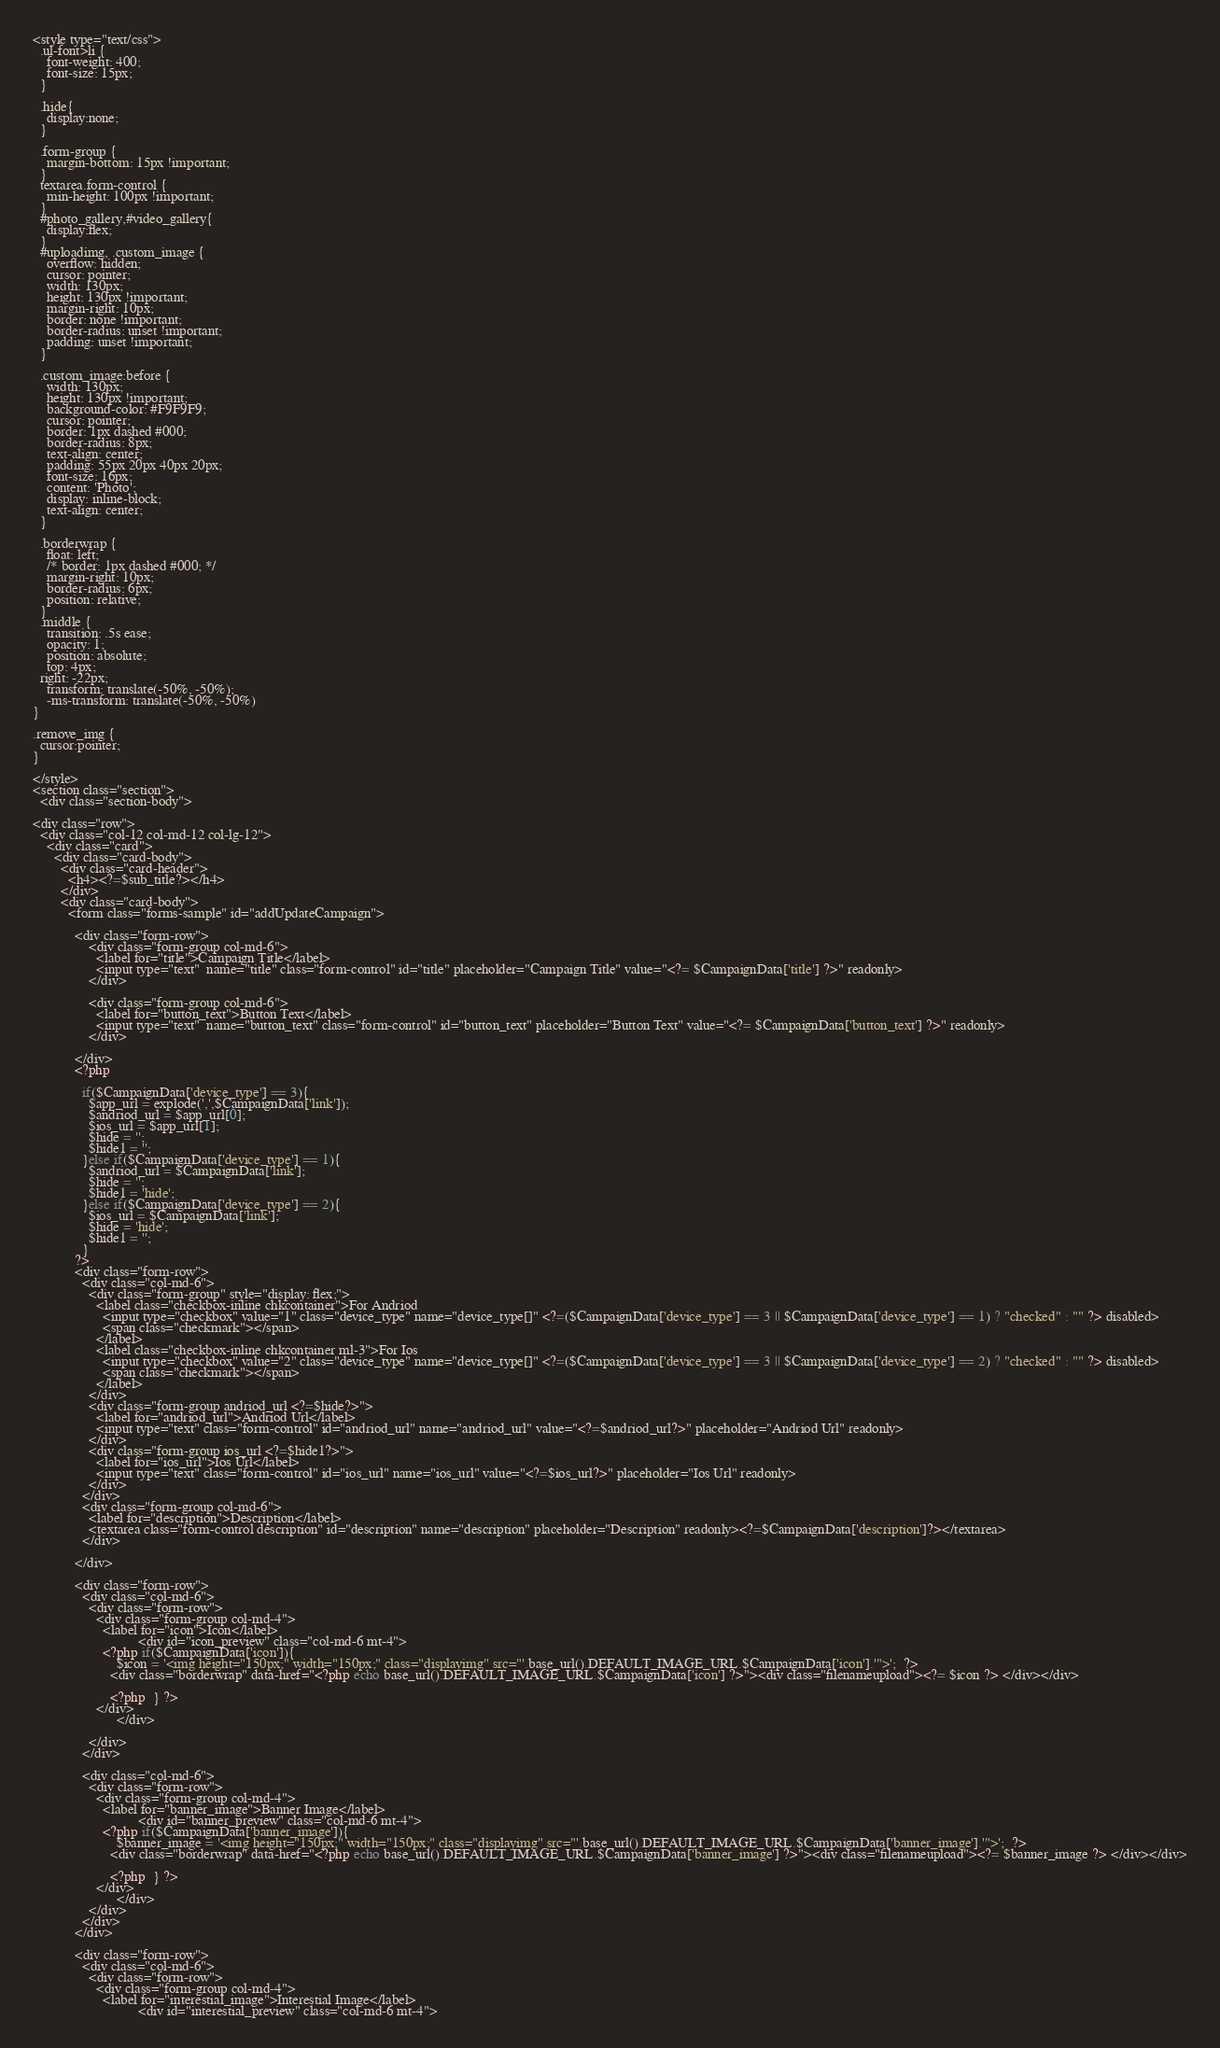<code> <loc_0><loc_0><loc_500><loc_500><_PHP_><style type="text/css">
  .ul-font>li {
    font-weight: 400;
    font-size: 15px;
  }

  .hide{
    display:none;
  }

  .form-group {
    margin-bottom: 15px !important;
  }
  textarea.form-control {
    min-height: 100px !important;
  }
  #photo_gallery,#video_gallery{
    display:flex;
  }
  #uploadimg, .custom_image {
    overflow: hidden;
    cursor: pointer;
    width: 130px;
    height: 130px !important;
    margin-right: 10px;
    border: none !important;
    border-radius: unset !important;
    padding: unset !important;
  }

  .custom_image:before {
    width: 130px;
    height: 130px !important;
    background-color: #F9F9F9;
    cursor: pointer;
    border: 1px dashed #000;
    border-radius: 8px;
    text-align: center;
    padding: 55px 20px 40px 20px;
    font-size: 16px;
    content: 'Photo';
    display: inline-block;
    text-align: center;
  }

  .borderwrap {
    float: left;
    /* border: 1px dashed #000; */
    margin-right: 10px;
    border-radius: 6px;
    position: relative;
  }
  .middle {
	transition: .5s ease;
	opacity: 1;
	position: absolute;
	top: 4px;
  right: -22px;
	transform: translate(-50%, -50%);
	-ms-transform: translate(-50%, -50%)
}

.remove_img {
  cursor:pointer;
}

</style>
<section class="section">
  <div class="section-body">

<div class="row">
  <div class="col-12 col-md-12 col-lg-12">
    <div class="card">
      <div class="card-body">
        <div class="card-header">
          <h4><?=$sub_title?></h4>
        </div>
        <div class="card-body">
          <form class="forms-sample" id="addUpdateCampaign"> 
            
            <div class="form-row">
                <div class="form-group col-md-6">
                  <label for="title">Campaign Title</label>
                  <input type="text"  name="title" class="form-control" id="title" placeholder="Campaign Title" value="<?= $CampaignData['title'] ?>" readonly>
                </div>

                <div class="form-group col-md-6">
                  <label for="button_text">Button Text</label>
                  <input type="text"  name="button_text" class="form-control" id="button_text" placeholder="Button Text" value="<?= $CampaignData['button_text'] ?>" readonly>
                </div>
                
            </div>
            <?php 

              if($CampaignData['device_type'] == 3){
                $app_url = explode(',',$CampaignData['link']);
                $andriod_url = $app_url[0];
                $ios_url = $app_url[1];
                $hide = '';
                $hide1 = '';
              }else if($CampaignData['device_type'] == 1){
                $andriod_url = $CampaignData['link'];
                $hide = '';
                $hide1 = 'hide';
              }else if($CampaignData['device_type'] == 2){
                $ios_url = $CampaignData['link'];
                $hide = 'hide';
                $hide1 = '';
              }
            ?>
            <div class="form-row">
              <div class="col-md-6">
                <div class="form-group" style="display: flex;">
                  <label class="checkbox-inline chkcontainer">For Andriod
                    <input type="checkbox" value="1" class="device_type" name="device_type[]" <?=($CampaignData['device_type'] == 3 || $CampaignData['device_type'] == 1) ? "checked" : "" ?> disabled>
                    <span class="checkmark"></span>
                  </label>
                  <label class="checkbox-inline chkcontainer ml-3">For Ios
                    <input type="checkbox" value="2" class="device_type" name="device_type[]" <?=($CampaignData['device_type'] == 3 || $CampaignData['device_type'] == 2) ? "checked" : "" ?> disabled>
                    <span class="checkmark"></span>
                  </label>
                </div>
                <div class="form-group andriod_url <?=$hide?>">
                  <label for="andriod_url">Andriod Url</label>
                  <input type="text" class="form-control" id="andriod_url" name="andriod_url" value="<?=$andriod_url?>" placeholder="Andriod Url" readonly>
                </div>
                <div class="form-group ios_url <?=$hide1?>">
                  <label for="ios_url">Ios Url</label>
                  <input type="text" class="form-control" id="ios_url" name="ios_url" value="<?=$ios_url?>" placeholder="Ios Url" readonly>
                </div>
              </div>
              <div class="form-group col-md-6">
                <label for="description">Description</label>
                <textarea class="form-control description" id="description" name="description" placeholder="Description" readonly><?=$CampaignData['description']?></textarea>
              </div>
                
            </div>

            <div class="form-row">
              <div class="col-md-6">
                <div class="form-row">
                  <div class="form-group col-md-4">
                    <label for="icon">Icon</label>
					          <div id="icon_preview" class="col-md-6 mt-4">
                    <?php if($CampaignData['icon']){ 
                        $icon = '<img height="150px;" width="150px;" class="displayimg" src="'.base_url().DEFAULT_IMAGE_URL.$CampaignData['icon'].'">';  ?>
                      <div class="borderwrap" data-href="<?php echo base_url().DEFAULT_IMAGE_URL.$CampaignData['icon'] ?>"><div class="filenameupload"><?= $icon ?> </div></div>

                      <?php  } ?>
                  </div>
				        </div>
                  
                </div>
              </div>

              <div class="col-md-6">
                <div class="form-row">
                  <div class="form-group col-md-4">
                    <label for="banner_image">Banner Image</label>
					          <div id="banner_preview" class="col-md-6 mt-4">
                    <?php if($CampaignData['banner_image']){ 
                        $banner_image = '<img height="150px;" width="150px;" class="displayimg" src="'.base_url().DEFAULT_IMAGE_URL.$CampaignData['banner_image'].'">';  ?>
                      <div class="borderwrap" data-href="<?php echo base_url().DEFAULT_IMAGE_URL.$CampaignData['banner_image'] ?>"><div class="filenameupload"><?= $banner_image ?> </div></div>

                      <?php  } ?>
                  </div>
				        </div>
                </div>
              </div>
            </div>
            
            <div class="form-row">
              <div class="col-md-6">
                <div class="form-row">
                  <div class="form-group col-md-4">
                    <label for="interestial_image">Interestial Image</label>
					          <div id="interestial_preview" class="col-md-6 mt-4"></code> 